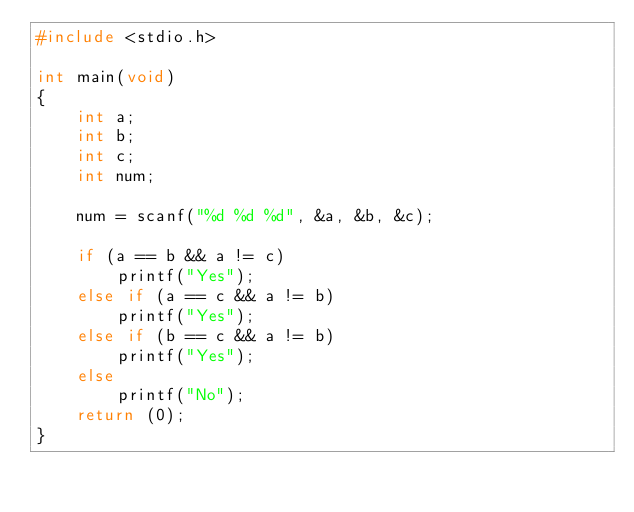Convert code to text. <code><loc_0><loc_0><loc_500><loc_500><_C_>#include <stdio.h>

int	main(void)
{
  	int	a;
  	int	b;
  	int	c;
  	int	num;
  
  	num = scanf("%d %d %d", &a, &b, &c);
  
  	if (a == b && a != c)
      	printf("Yes");
  	else if (a == c && a != b)
      	printf("Yes");
  	else if (b == c && a != b)
      	printf("Yes");
  	else
      	printf("No");
  	return (0);
}


      </code> 